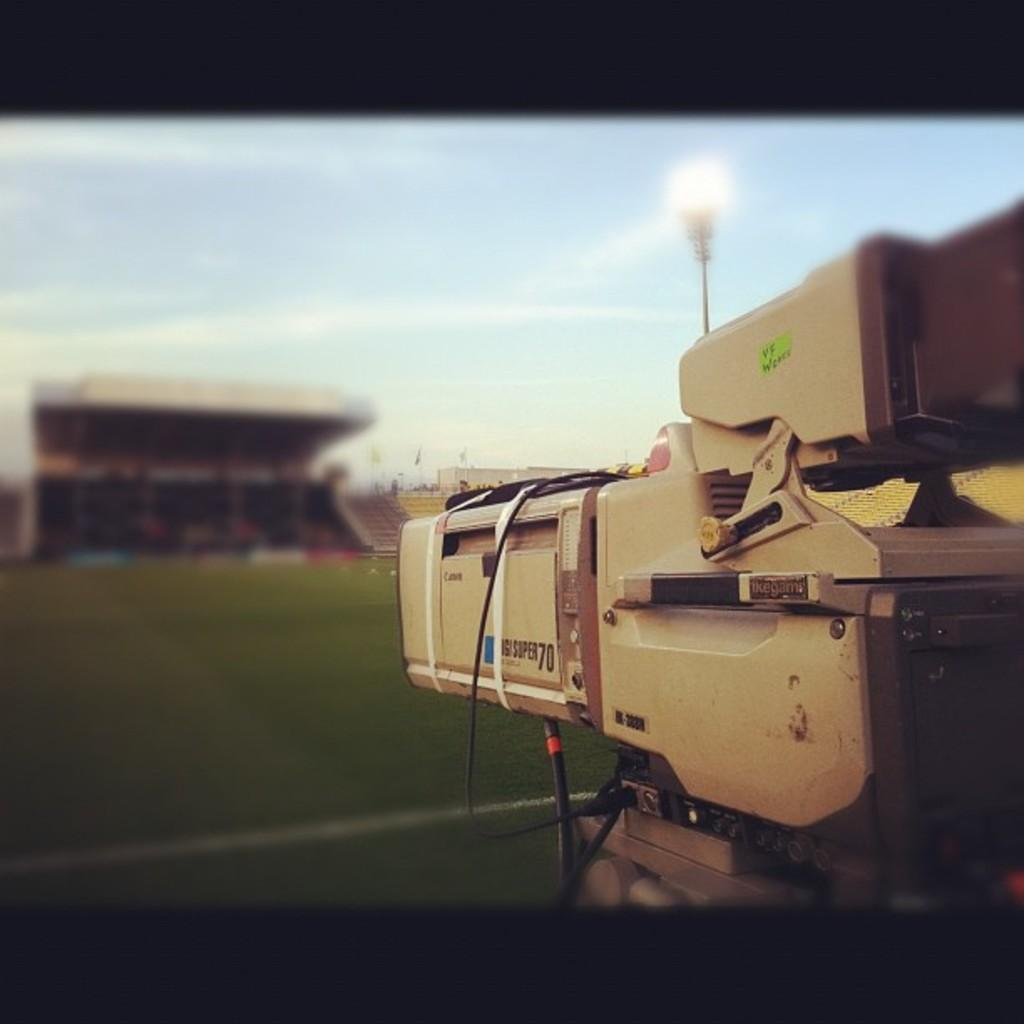What object is the main focus of the image? There is a camera in the image. What can be seen beneath the camera? The ground is visible in the image. What type of lighting equipment is present in the image? There is a flood light in the image. What type of location is suggested by the background of the image? The background of the image appears to be a stadium. What is visible in the sky at the top of the image? Clouds are visible in the sky at the top of the image. What team is currently playing in the stadium in the image? There is no indication of a team playing in the stadium in the image. How does the camera show respect to the players in the image? The camera itself does not show respect; it is an inanimate object. Respect is a human emotion and cannot be attributed to an object. 